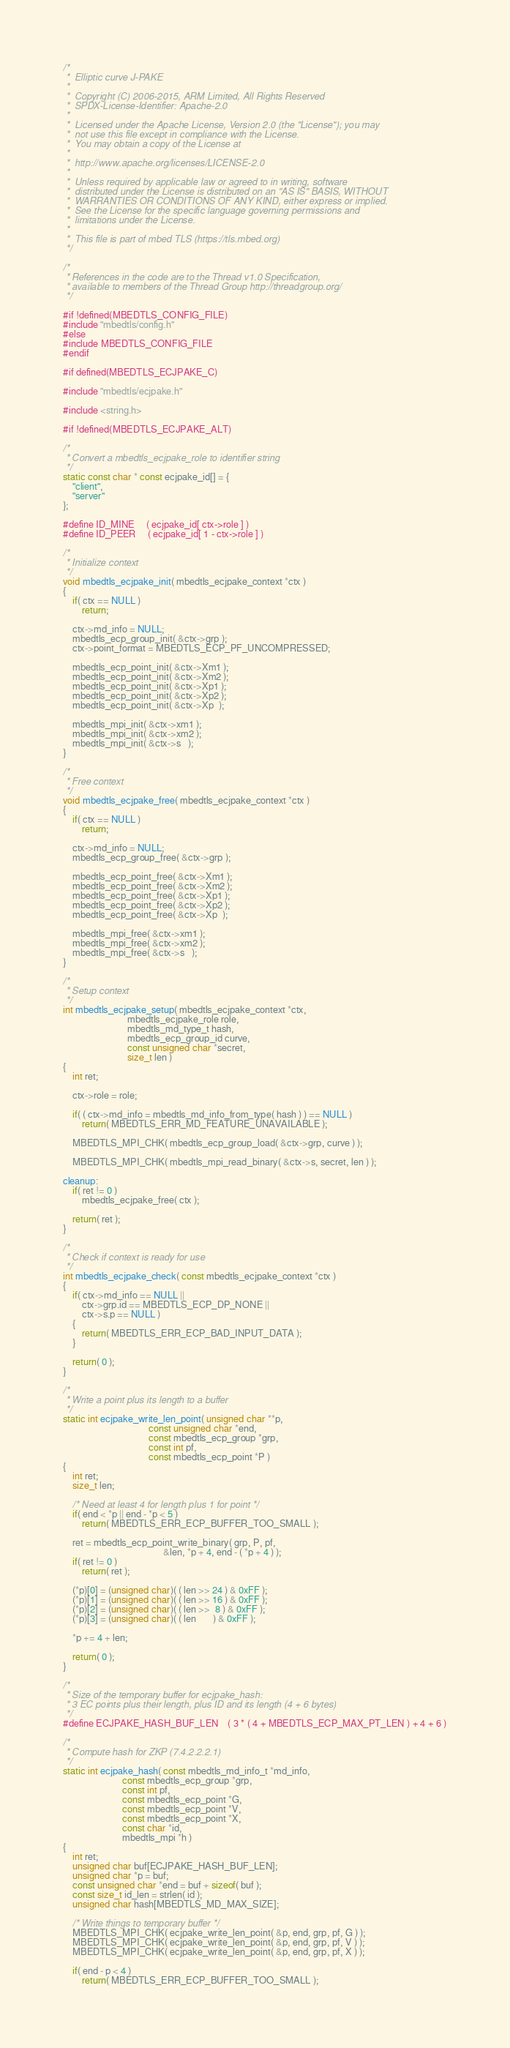Convert code to text. <code><loc_0><loc_0><loc_500><loc_500><_C_>/*
 *  Elliptic curve J-PAKE
 *
 *  Copyright (C) 2006-2015, ARM Limited, All Rights Reserved
 *  SPDX-License-Identifier: Apache-2.0
 *
 *  Licensed under the Apache License, Version 2.0 (the "License"); you may
 *  not use this file except in compliance with the License.
 *  You may obtain a copy of the License at
 *
 *  http://www.apache.org/licenses/LICENSE-2.0
 *
 *  Unless required by applicable law or agreed to in writing, software
 *  distributed under the License is distributed on an "AS IS" BASIS, WITHOUT
 *  WARRANTIES OR CONDITIONS OF ANY KIND, either express or implied.
 *  See the License for the specific language governing permissions and
 *  limitations under the License.
 *
 *  This file is part of mbed TLS (https://tls.mbed.org)
 */

/*
 * References in the code are to the Thread v1.0 Specification,
 * available to members of the Thread Group http://threadgroup.org/
 */

#if !defined(MBEDTLS_CONFIG_FILE)
#include "mbedtls/config.h"
#else
#include MBEDTLS_CONFIG_FILE
#endif

#if defined(MBEDTLS_ECJPAKE_C)

#include "mbedtls/ecjpake.h"

#include <string.h>

#if !defined(MBEDTLS_ECJPAKE_ALT)

/*
 * Convert a mbedtls_ecjpake_role to identifier string
 */
static const char * const ecjpake_id[] = {
    "client",
    "server"
};

#define ID_MINE     ( ecjpake_id[ ctx->role ] )
#define ID_PEER     ( ecjpake_id[ 1 - ctx->role ] )

/*
 * Initialize context
 */
void mbedtls_ecjpake_init( mbedtls_ecjpake_context *ctx )
{
    if( ctx == NULL )
        return;

    ctx->md_info = NULL;
    mbedtls_ecp_group_init( &ctx->grp );
    ctx->point_format = MBEDTLS_ECP_PF_UNCOMPRESSED;

    mbedtls_ecp_point_init( &ctx->Xm1 );
    mbedtls_ecp_point_init( &ctx->Xm2 );
    mbedtls_ecp_point_init( &ctx->Xp1 );
    mbedtls_ecp_point_init( &ctx->Xp2 );
    mbedtls_ecp_point_init( &ctx->Xp  );

    mbedtls_mpi_init( &ctx->xm1 );
    mbedtls_mpi_init( &ctx->xm2 );
    mbedtls_mpi_init( &ctx->s   );
}

/*
 * Free context
 */
void mbedtls_ecjpake_free( mbedtls_ecjpake_context *ctx )
{
    if( ctx == NULL )
        return;

    ctx->md_info = NULL;
    mbedtls_ecp_group_free( &ctx->grp );

    mbedtls_ecp_point_free( &ctx->Xm1 );
    mbedtls_ecp_point_free( &ctx->Xm2 );
    mbedtls_ecp_point_free( &ctx->Xp1 );
    mbedtls_ecp_point_free( &ctx->Xp2 );
    mbedtls_ecp_point_free( &ctx->Xp  );

    mbedtls_mpi_free( &ctx->xm1 );
    mbedtls_mpi_free( &ctx->xm2 );
    mbedtls_mpi_free( &ctx->s   );
}

/*
 * Setup context
 */
int mbedtls_ecjpake_setup( mbedtls_ecjpake_context *ctx,
                           mbedtls_ecjpake_role role,
                           mbedtls_md_type_t hash,
                           mbedtls_ecp_group_id curve,
                           const unsigned char *secret,
                           size_t len )
{
    int ret;

    ctx->role = role;

    if( ( ctx->md_info = mbedtls_md_info_from_type( hash ) ) == NULL )
        return( MBEDTLS_ERR_MD_FEATURE_UNAVAILABLE );

    MBEDTLS_MPI_CHK( mbedtls_ecp_group_load( &ctx->grp, curve ) );

    MBEDTLS_MPI_CHK( mbedtls_mpi_read_binary( &ctx->s, secret, len ) );

cleanup:
    if( ret != 0 )
        mbedtls_ecjpake_free( ctx );

    return( ret );
}

/*
 * Check if context is ready for use
 */
int mbedtls_ecjpake_check( const mbedtls_ecjpake_context *ctx )
{
    if( ctx->md_info == NULL ||
        ctx->grp.id == MBEDTLS_ECP_DP_NONE ||
        ctx->s.p == NULL )
    {
        return( MBEDTLS_ERR_ECP_BAD_INPUT_DATA );
    }

    return( 0 );
}

/*
 * Write a point plus its length to a buffer
 */
static int ecjpake_write_len_point( unsigned char **p,
                                    const unsigned char *end,
                                    const mbedtls_ecp_group *grp,
                                    const int pf,
                                    const mbedtls_ecp_point *P )
{
    int ret;
    size_t len;

    /* Need at least 4 for length plus 1 for point */
    if( end < *p || end - *p < 5 )
        return( MBEDTLS_ERR_ECP_BUFFER_TOO_SMALL );

    ret = mbedtls_ecp_point_write_binary( grp, P, pf,
                                          &len, *p + 4, end - ( *p + 4 ) );
    if( ret != 0 )
        return( ret );

    (*p)[0] = (unsigned char)( ( len >> 24 ) & 0xFF );
    (*p)[1] = (unsigned char)( ( len >> 16 ) & 0xFF );
    (*p)[2] = (unsigned char)( ( len >>  8 ) & 0xFF );
    (*p)[3] = (unsigned char)( ( len       ) & 0xFF );

    *p += 4 + len;

    return( 0 );
}

/*
 * Size of the temporary buffer for ecjpake_hash:
 * 3 EC points plus their length, plus ID and its length (4 + 6 bytes)
 */
#define ECJPAKE_HASH_BUF_LEN    ( 3 * ( 4 + MBEDTLS_ECP_MAX_PT_LEN ) + 4 + 6 )

/*
 * Compute hash for ZKP (7.4.2.2.2.1)
 */
static int ecjpake_hash( const mbedtls_md_info_t *md_info,
                         const mbedtls_ecp_group *grp,
                         const int pf,
                         const mbedtls_ecp_point *G,
                         const mbedtls_ecp_point *V,
                         const mbedtls_ecp_point *X,
                         const char *id,
                         mbedtls_mpi *h )
{
    int ret;
    unsigned char buf[ECJPAKE_HASH_BUF_LEN];
    unsigned char *p = buf;
    const unsigned char *end = buf + sizeof( buf );
    const size_t id_len = strlen( id );
    unsigned char hash[MBEDTLS_MD_MAX_SIZE];

    /* Write things to temporary buffer */
    MBEDTLS_MPI_CHK( ecjpake_write_len_point( &p, end, grp, pf, G ) );
    MBEDTLS_MPI_CHK( ecjpake_write_len_point( &p, end, grp, pf, V ) );
    MBEDTLS_MPI_CHK( ecjpake_write_len_point( &p, end, grp, pf, X ) );

    if( end - p < 4 )
        return( MBEDTLS_ERR_ECP_BUFFER_TOO_SMALL );
</code> 